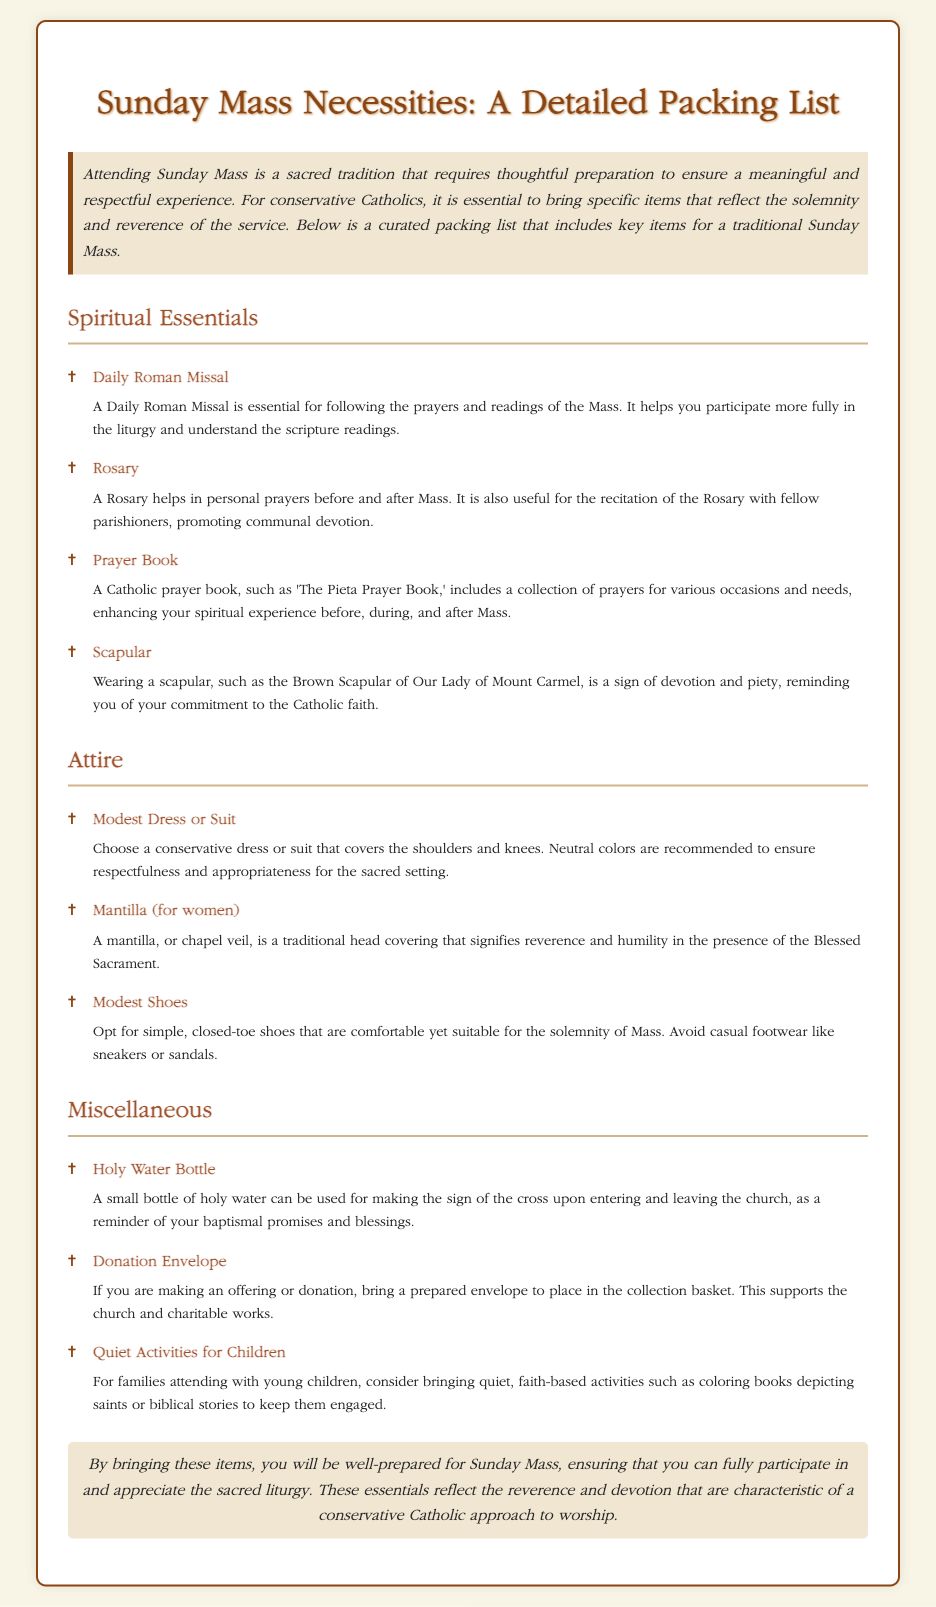What are the spiritual essentials listed? The spiritual essentials include items like the Daily Roman Missal, Rosary, Prayer Book, and Scapular.
Answer: Daily Roman Missal, Rosary, Prayer Book, Scapular What type of attire is suggested for Mass? The document recommends wearing a modest dress or suit, with specifications about coverage and colors.
Answer: Modest Dress or Suit What is the purpose of bringing a Rosary? The Rosary is suggested for personal prayers and communal devotion before and after Mass.
Answer: Personal prayers and communal devotion How many miscellaneous items are mentioned? The document lists three miscellaneous items as part of the packing list.
Answer: Three What does a mantilla signify? The mantilla is indicated as a traditional head covering that signifies reverence and humility.
Answer: Reverence and humility Why is a donation envelope important? Bringing a donation envelope is important for making an offering to support the church and its charitable works.
Answer: For making an offering What is emphasized about the Sunday Mass essentials? The conclusion emphasizes that these items reflect the reverence and devotion characteristic of a conservative Catholic approach.
Answer: Reflect reverence and devotion What is included in the spiritual essentials that involves scripture readings? The item that helps with participating in prayers and readings during the Mass is the Daily Roman Missal.
Answer: Daily Roman Missal 